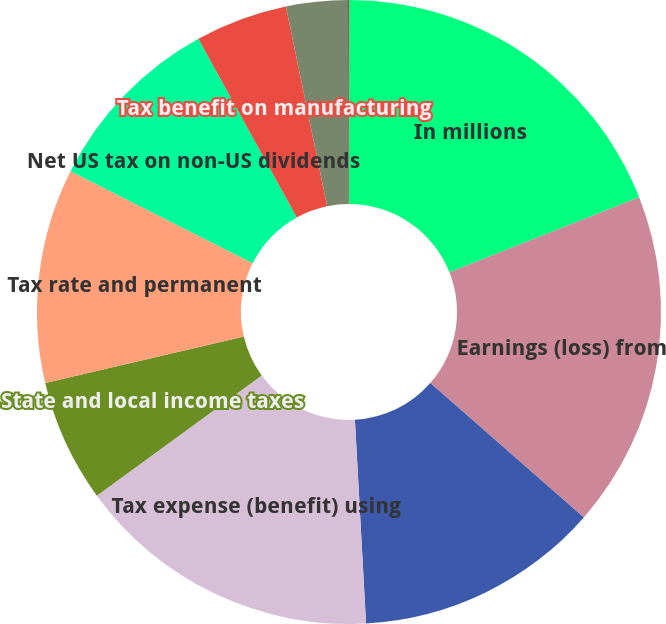<chart> <loc_0><loc_0><loc_500><loc_500><pie_chart><fcel>In millions<fcel>Earnings (loss) from<fcel>Statutory US income tax rate<fcel>Tax expense (benefit) using<fcel>State and local income taxes<fcel>Tax rate and permanent<fcel>Net US tax on non-US dividends<fcel>Tax benefit on manufacturing<fcel>Non-deductible business<fcel>Retirement plan dividends<nl><fcel>19.01%<fcel>17.43%<fcel>12.69%<fcel>15.85%<fcel>6.36%<fcel>11.11%<fcel>9.53%<fcel>4.78%<fcel>3.2%<fcel>0.04%<nl></chart> 